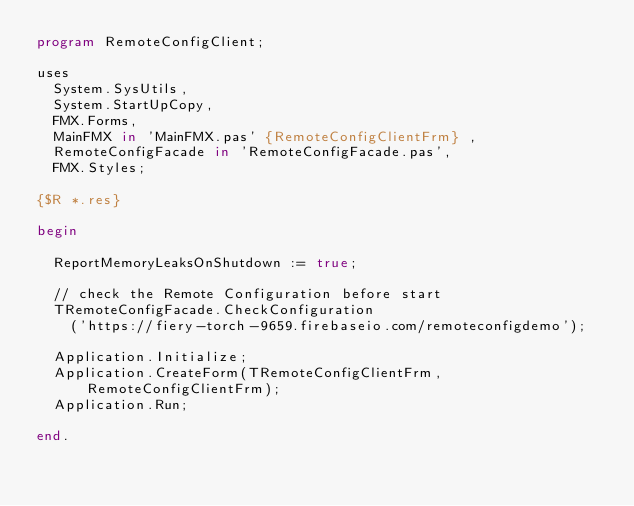Convert code to text. <code><loc_0><loc_0><loc_500><loc_500><_Pascal_>program RemoteConfigClient;

uses
  System.SysUtils,
  System.StartUpCopy,
  FMX.Forms,
  MainFMX in 'MainFMX.pas' {RemoteConfigClientFrm} ,
  RemoteConfigFacade in 'RemoteConfigFacade.pas',
  FMX.Styles;

{$R *.res}

begin

  ReportMemoryLeaksOnShutdown := true;

  // check the Remote Configuration before start
  TRemoteConfigFacade.CheckConfiguration
    ('https://fiery-torch-9659.firebaseio.com/remoteconfigdemo');

  Application.Initialize;
  Application.CreateForm(TRemoteConfigClientFrm, RemoteConfigClientFrm);
  Application.Run;

end.
</code> 